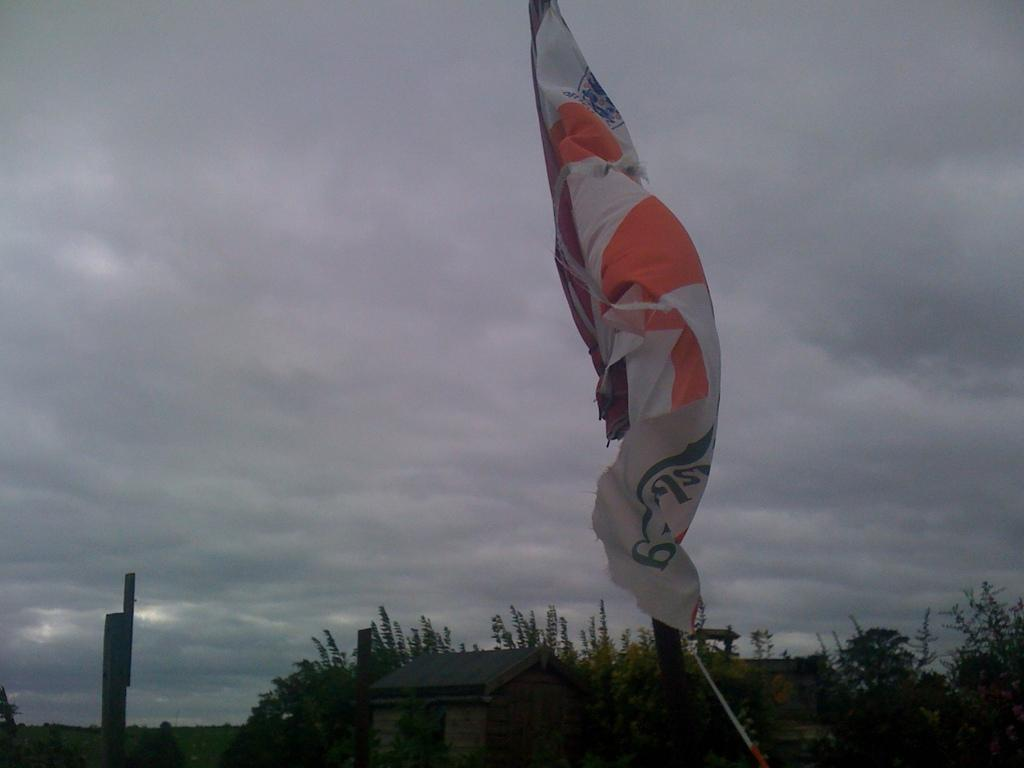What is located at the front of the image? There is a white flag in the front of the image. What type of structure can be seen in the image? There is a small shed house in the image. What type of vegetation is present in the image? There are trees in the image. What is the condition of the sky in the image? The sky is cloudy and visible in the image. Can you see a sock hanging from the tree in the image? There is no sock present in the image; only a white flag, a shed house, trees, and a cloudy sky are visible. 